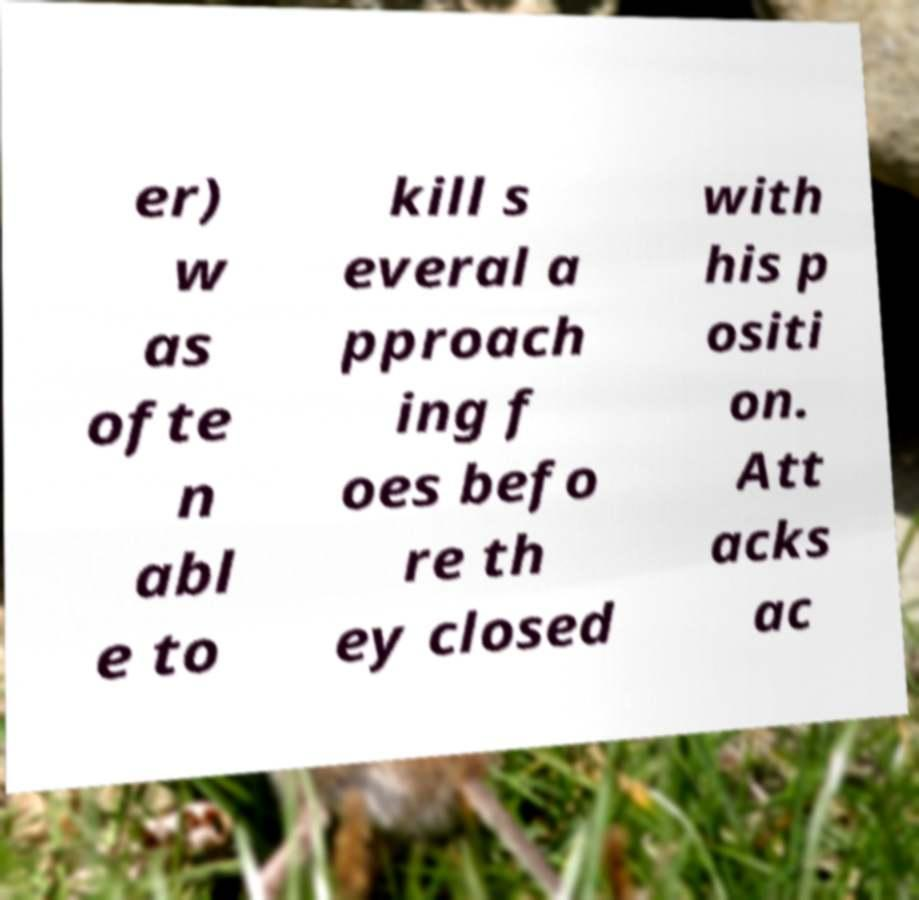Please read and relay the text visible in this image. What does it say? er) w as ofte n abl e to kill s everal a pproach ing f oes befo re th ey closed with his p ositi on. Att acks ac 